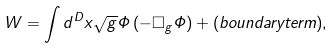Convert formula to latex. <formula><loc_0><loc_0><loc_500><loc_500>W = \int d ^ { D } x \sqrt { g } \Phi \left ( - \Box _ { g } \Phi \right ) + ( b o u n d a r y t e r m ) ,</formula> 